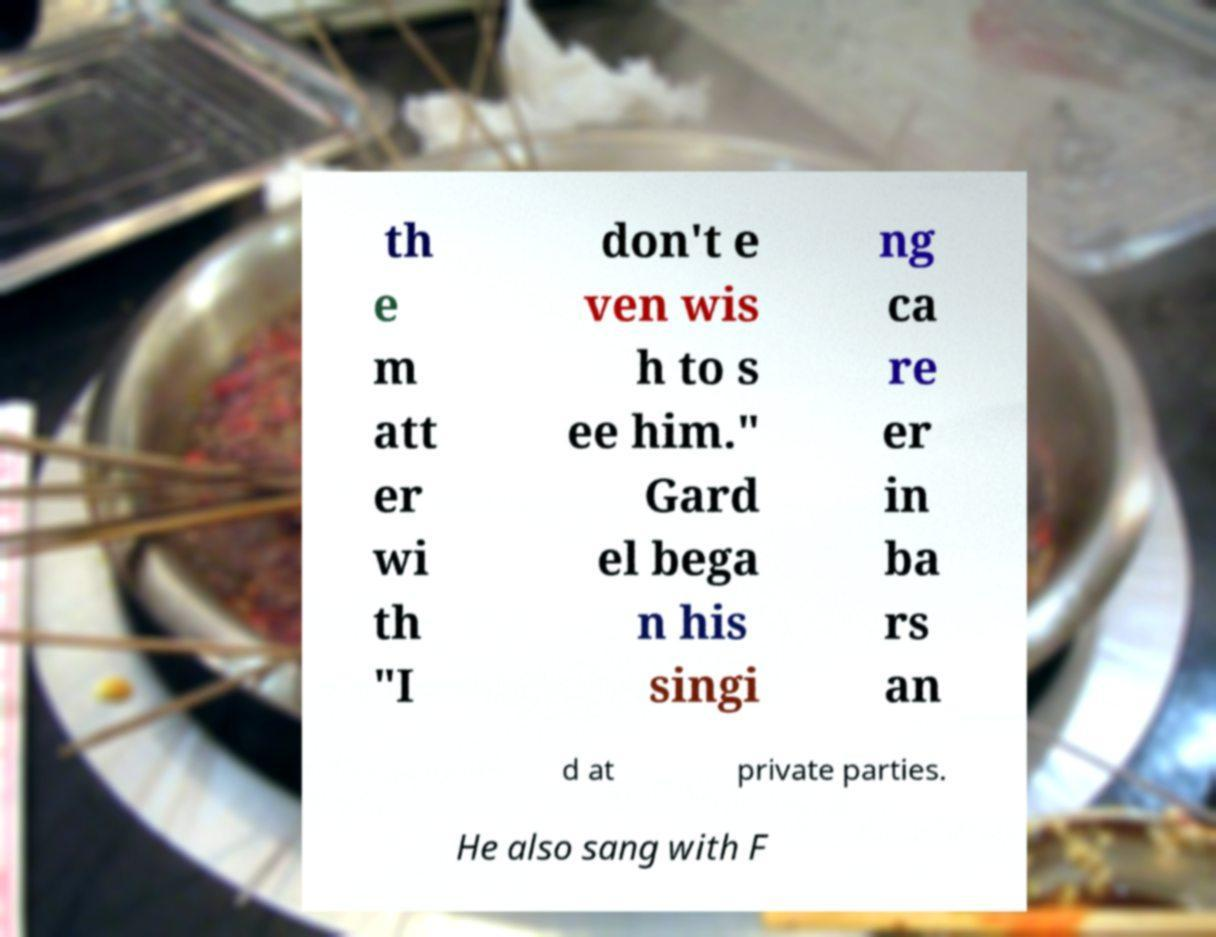For documentation purposes, I need the text within this image transcribed. Could you provide that? th e m att er wi th "I don't e ven wis h to s ee him." Gard el bega n his singi ng ca re er in ba rs an d at private parties. He also sang with F 